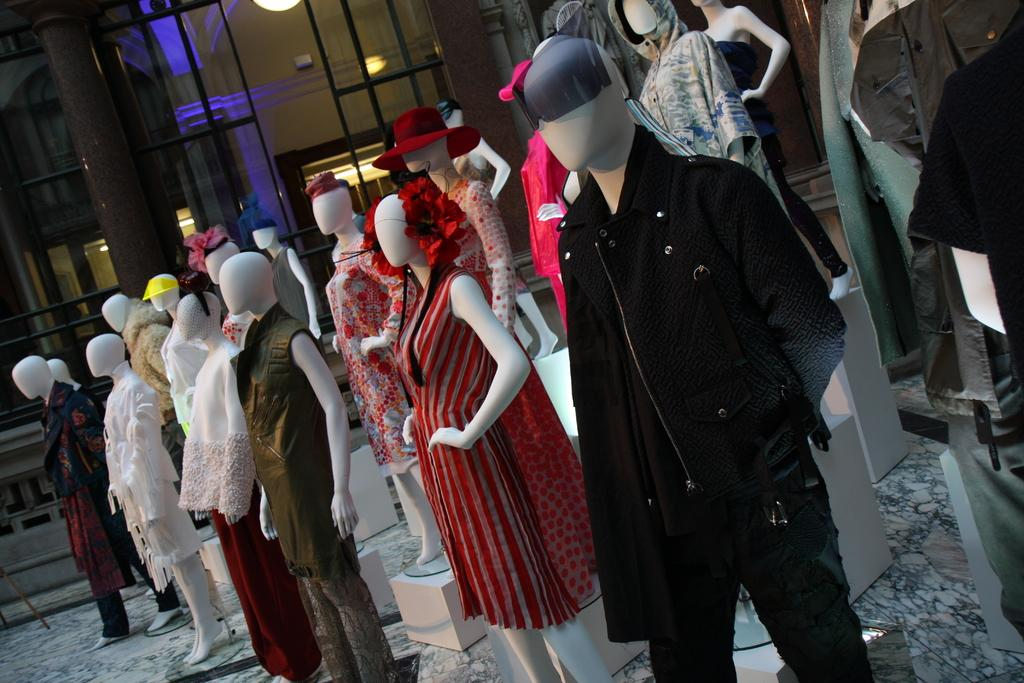What types of dolls are in the image? There are men and women dolls in the image. What are the men dolls wearing? The men dolls are wearing dresses. What can be seen in the background of the image? There is a building, glass doors, lights, and poles in the background of the image. What type of lace is used to decorate the tin in the image? There is no tin or lace present in the image. What is the source of power for the lights in the image? The source of power for the lights is not visible in the image. 